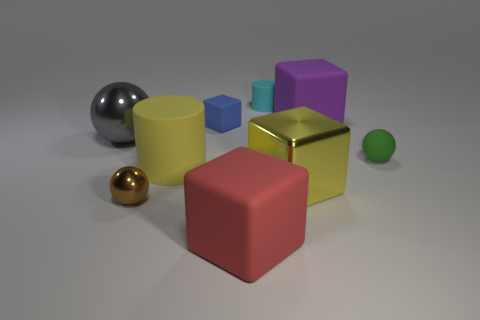Is there a red thing?
Keep it short and to the point. Yes. There is another large object that is the same shape as the brown object; what is its color?
Ensure brevity in your answer.  Gray. There is another sphere that is the same size as the brown shiny ball; what is its color?
Keep it short and to the point. Green. Are the tiny brown object and the gray object made of the same material?
Your response must be concise. Yes. What number of matte things have the same color as the metallic cube?
Ensure brevity in your answer.  1. Is the large cylinder the same color as the large shiny cube?
Your answer should be compact. Yes. What is the cylinder that is in front of the big gray thing made of?
Your answer should be compact. Rubber. How many big things are blue metallic spheres or blue matte things?
Provide a succinct answer. 0. There is a cube that is the same color as the big cylinder; what material is it?
Your answer should be compact. Metal. Is there a small purple cylinder made of the same material as the gray ball?
Make the answer very short. No. 